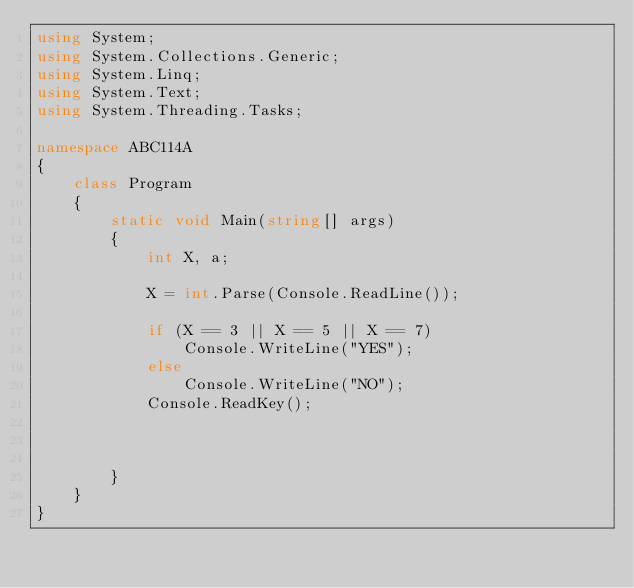Convert code to text. <code><loc_0><loc_0><loc_500><loc_500><_C#_>using System;
using System.Collections.Generic;
using System.Linq;
using System.Text;
using System.Threading.Tasks;

namespace ABC114A
{
    class Program
    {
        static void Main(string[] args)
        {
            int X, a;

            X = int.Parse(Console.ReadLine());

            if (X == 3 || X == 5 || X == 7)
                Console.WriteLine("YES");
            else
                Console.WriteLine("NO");
            Console.ReadKey();



        }
    }
}
</code> 